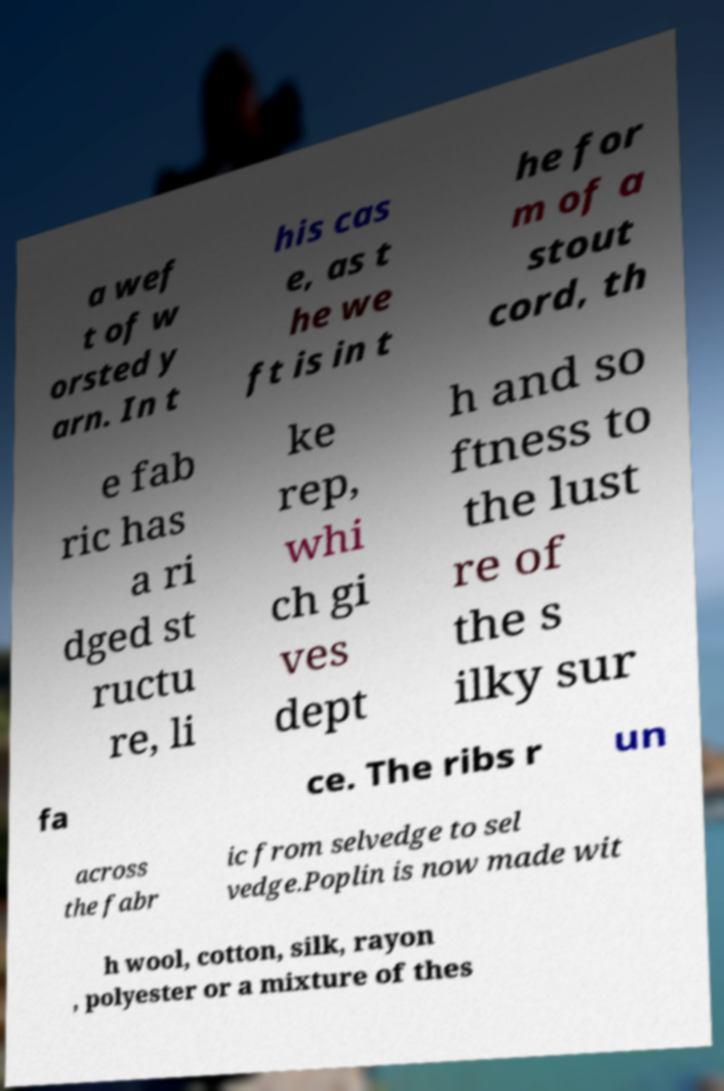For documentation purposes, I need the text within this image transcribed. Could you provide that? a wef t of w orsted y arn. In t his cas e, as t he we ft is in t he for m of a stout cord, th e fab ric has a ri dged st ructu re, li ke rep, whi ch gi ves dept h and so ftness to the lust re of the s ilky sur fa ce. The ribs r un across the fabr ic from selvedge to sel vedge.Poplin is now made wit h wool, cotton, silk, rayon , polyester or a mixture of thes 